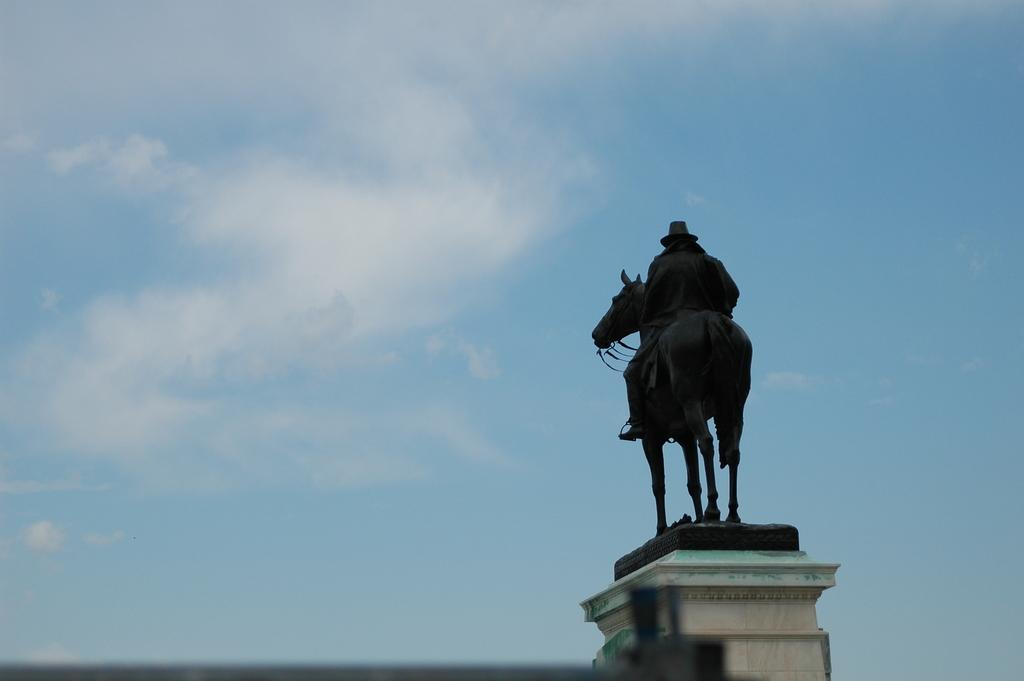What is the main subject of the image? There is a statue of a man on a horse in the image. Can you describe the background of the image? There is a cloud in the background of the image. How does the statue provide comfort to the horse in the image? The statue does not provide comfort to the horse, as it is a stationary object and not capable of providing comfort. 